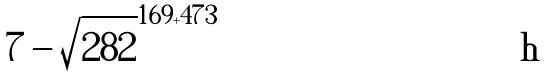<formula> <loc_0><loc_0><loc_500><loc_500>7 - \sqrt { 2 8 2 } ^ { 1 6 9 + 4 7 3 }</formula> 